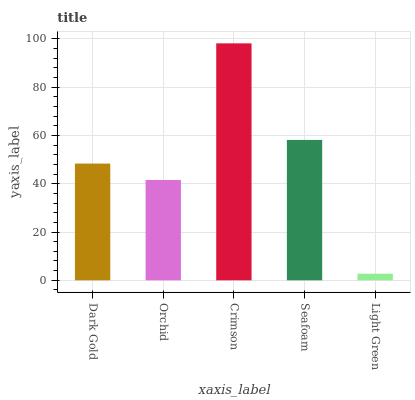Is Light Green the minimum?
Answer yes or no. Yes. Is Crimson the maximum?
Answer yes or no. Yes. Is Orchid the minimum?
Answer yes or no. No. Is Orchid the maximum?
Answer yes or no. No. Is Dark Gold greater than Orchid?
Answer yes or no. Yes. Is Orchid less than Dark Gold?
Answer yes or no. Yes. Is Orchid greater than Dark Gold?
Answer yes or no. No. Is Dark Gold less than Orchid?
Answer yes or no. No. Is Dark Gold the high median?
Answer yes or no. Yes. Is Dark Gold the low median?
Answer yes or no. Yes. Is Orchid the high median?
Answer yes or no. No. Is Orchid the low median?
Answer yes or no. No. 